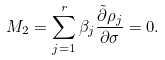<formula> <loc_0><loc_0><loc_500><loc_500>M _ { 2 } = \sum _ { j = 1 } ^ { r } \beta _ { j } \frac { \tilde { \partial } \rho _ { j } } { \partial \sigma } = 0 .</formula> 